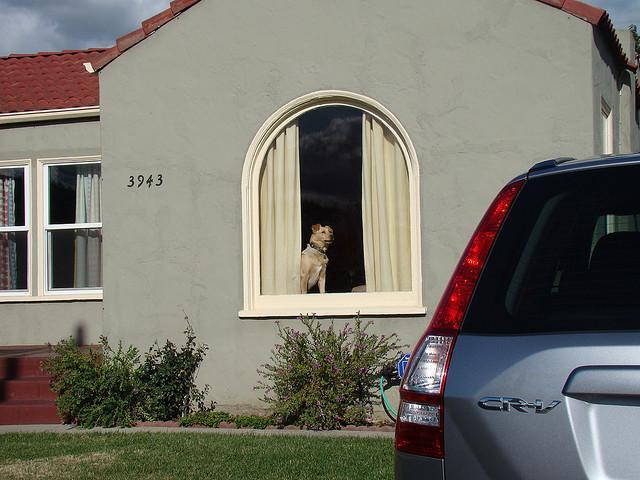How many people have a blue and white striped shirt?
Give a very brief answer. 0. 